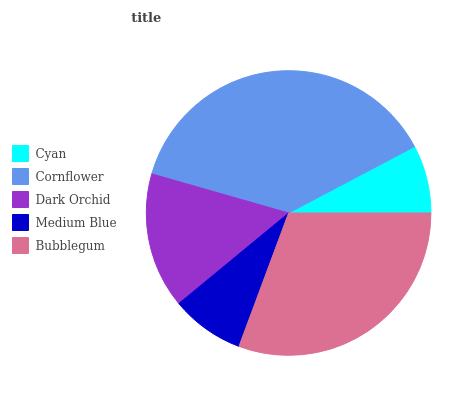Is Cyan the minimum?
Answer yes or no. Yes. Is Cornflower the maximum?
Answer yes or no. Yes. Is Dark Orchid the minimum?
Answer yes or no. No. Is Dark Orchid the maximum?
Answer yes or no. No. Is Cornflower greater than Dark Orchid?
Answer yes or no. Yes. Is Dark Orchid less than Cornflower?
Answer yes or no. Yes. Is Dark Orchid greater than Cornflower?
Answer yes or no. No. Is Cornflower less than Dark Orchid?
Answer yes or no. No. Is Dark Orchid the high median?
Answer yes or no. Yes. Is Dark Orchid the low median?
Answer yes or no. Yes. Is Cornflower the high median?
Answer yes or no. No. Is Cyan the low median?
Answer yes or no. No. 